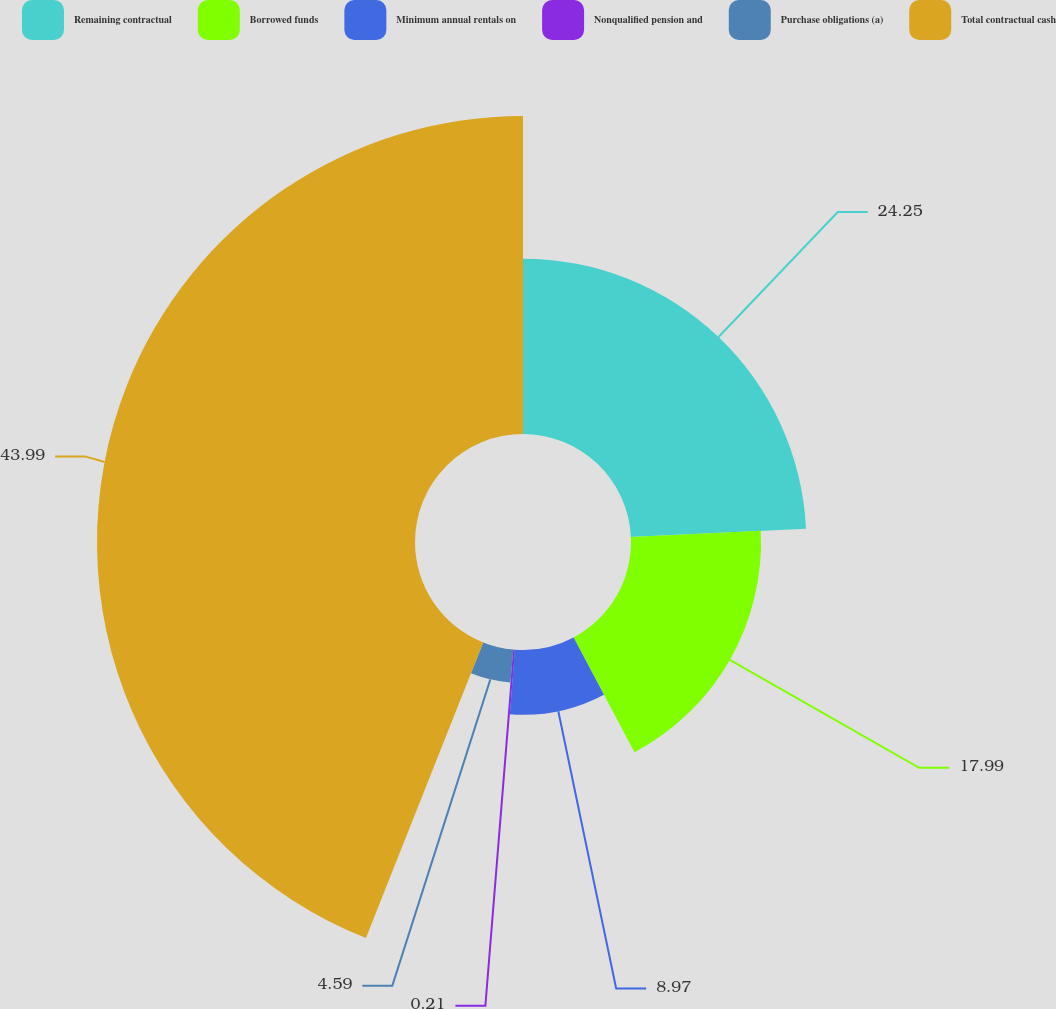<chart> <loc_0><loc_0><loc_500><loc_500><pie_chart><fcel>Remaining contractual<fcel>Borrowed funds<fcel>Minimum annual rentals on<fcel>Nonqualified pension and<fcel>Purchase obligations (a)<fcel>Total contractual cash<nl><fcel>24.25%<fcel>17.99%<fcel>8.97%<fcel>0.21%<fcel>4.59%<fcel>43.99%<nl></chart> 